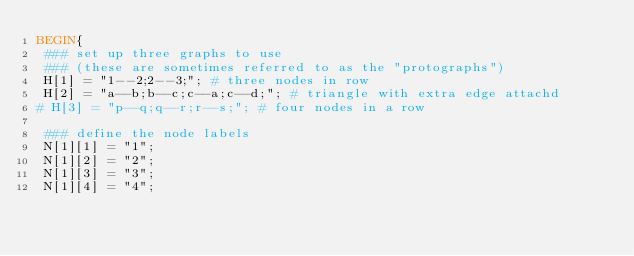<code> <loc_0><loc_0><loc_500><loc_500><_Awk_>BEGIN{
 ### set up three graphs to use
 ### (these are sometimes referred to as the "protographs")
 H[1] = "1--2;2--3;"; # three nodes in row
 H[2] = "a--b;b--c;c--a;c--d;"; # triangle with extra edge attachd
# H[3] = "p--q;q--r;r--s;"; # four nodes in a row

 ### define the node labels
 N[1][1] = "1";
 N[1][2] = "2";
 N[1][3] = "3";
 N[1][4] = "4";
</code> 